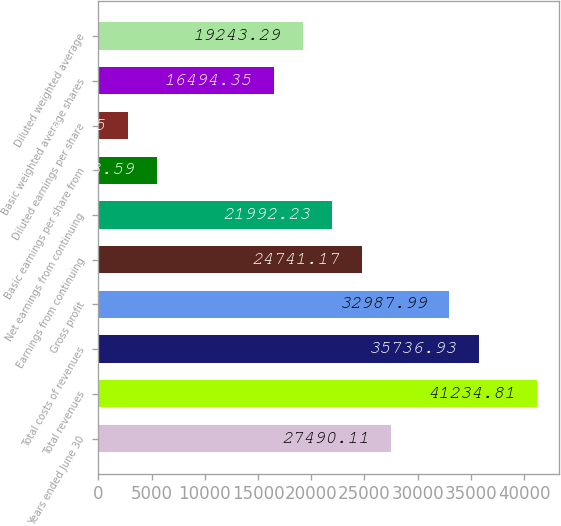Convert chart. <chart><loc_0><loc_0><loc_500><loc_500><bar_chart><fcel>Years ended June 30<fcel>Total revenues<fcel>Total costs of revenues<fcel>Gross profit<fcel>Earnings from continuing<fcel>Net earnings from continuing<fcel>Basic earnings per share from<fcel>Diluted earnings per share<fcel>Basic weighted average shares<fcel>Diluted weighted average<nl><fcel>27490.1<fcel>41234.8<fcel>35736.9<fcel>32988<fcel>24741.2<fcel>21992.2<fcel>5498.59<fcel>2749.65<fcel>16494.3<fcel>19243.3<nl></chart> 